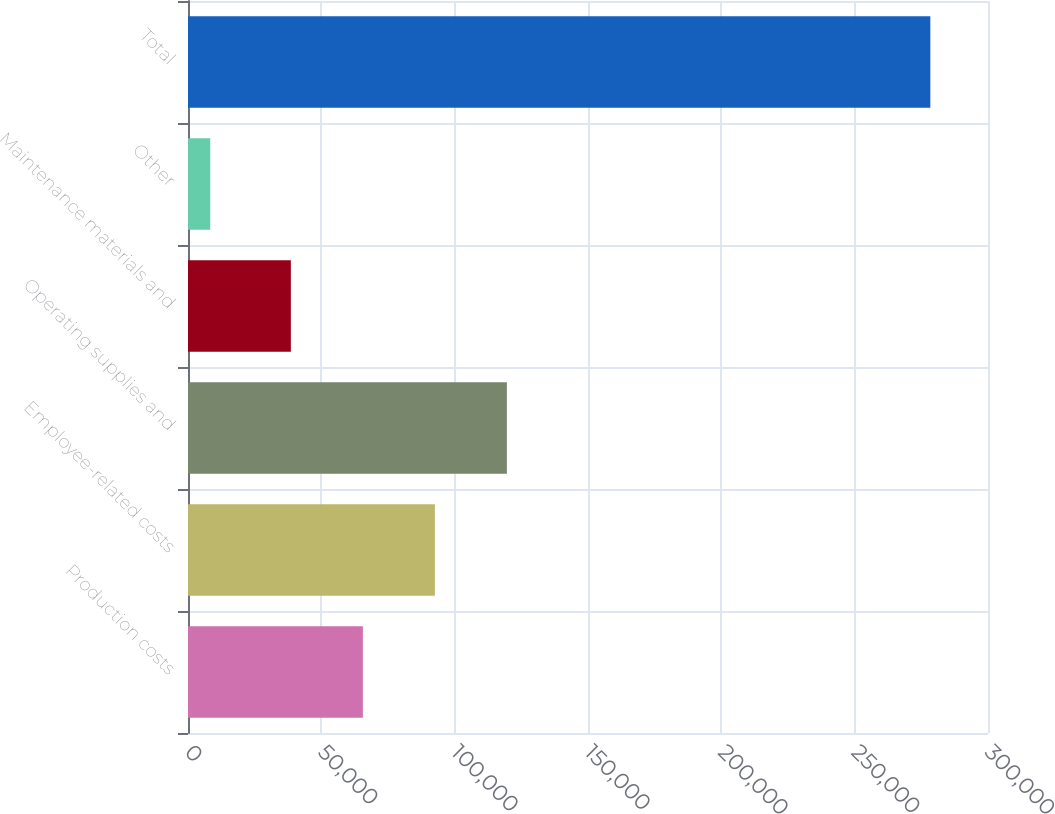Convert chart. <chart><loc_0><loc_0><loc_500><loc_500><bar_chart><fcel>Production costs<fcel>Employee-related costs<fcel>Operating supplies and<fcel>Maintenance materials and<fcel>Other<fcel>Total<nl><fcel>65570.9<fcel>92573.8<fcel>119577<fcel>38568<fcel>8346<fcel>278375<nl></chart> 